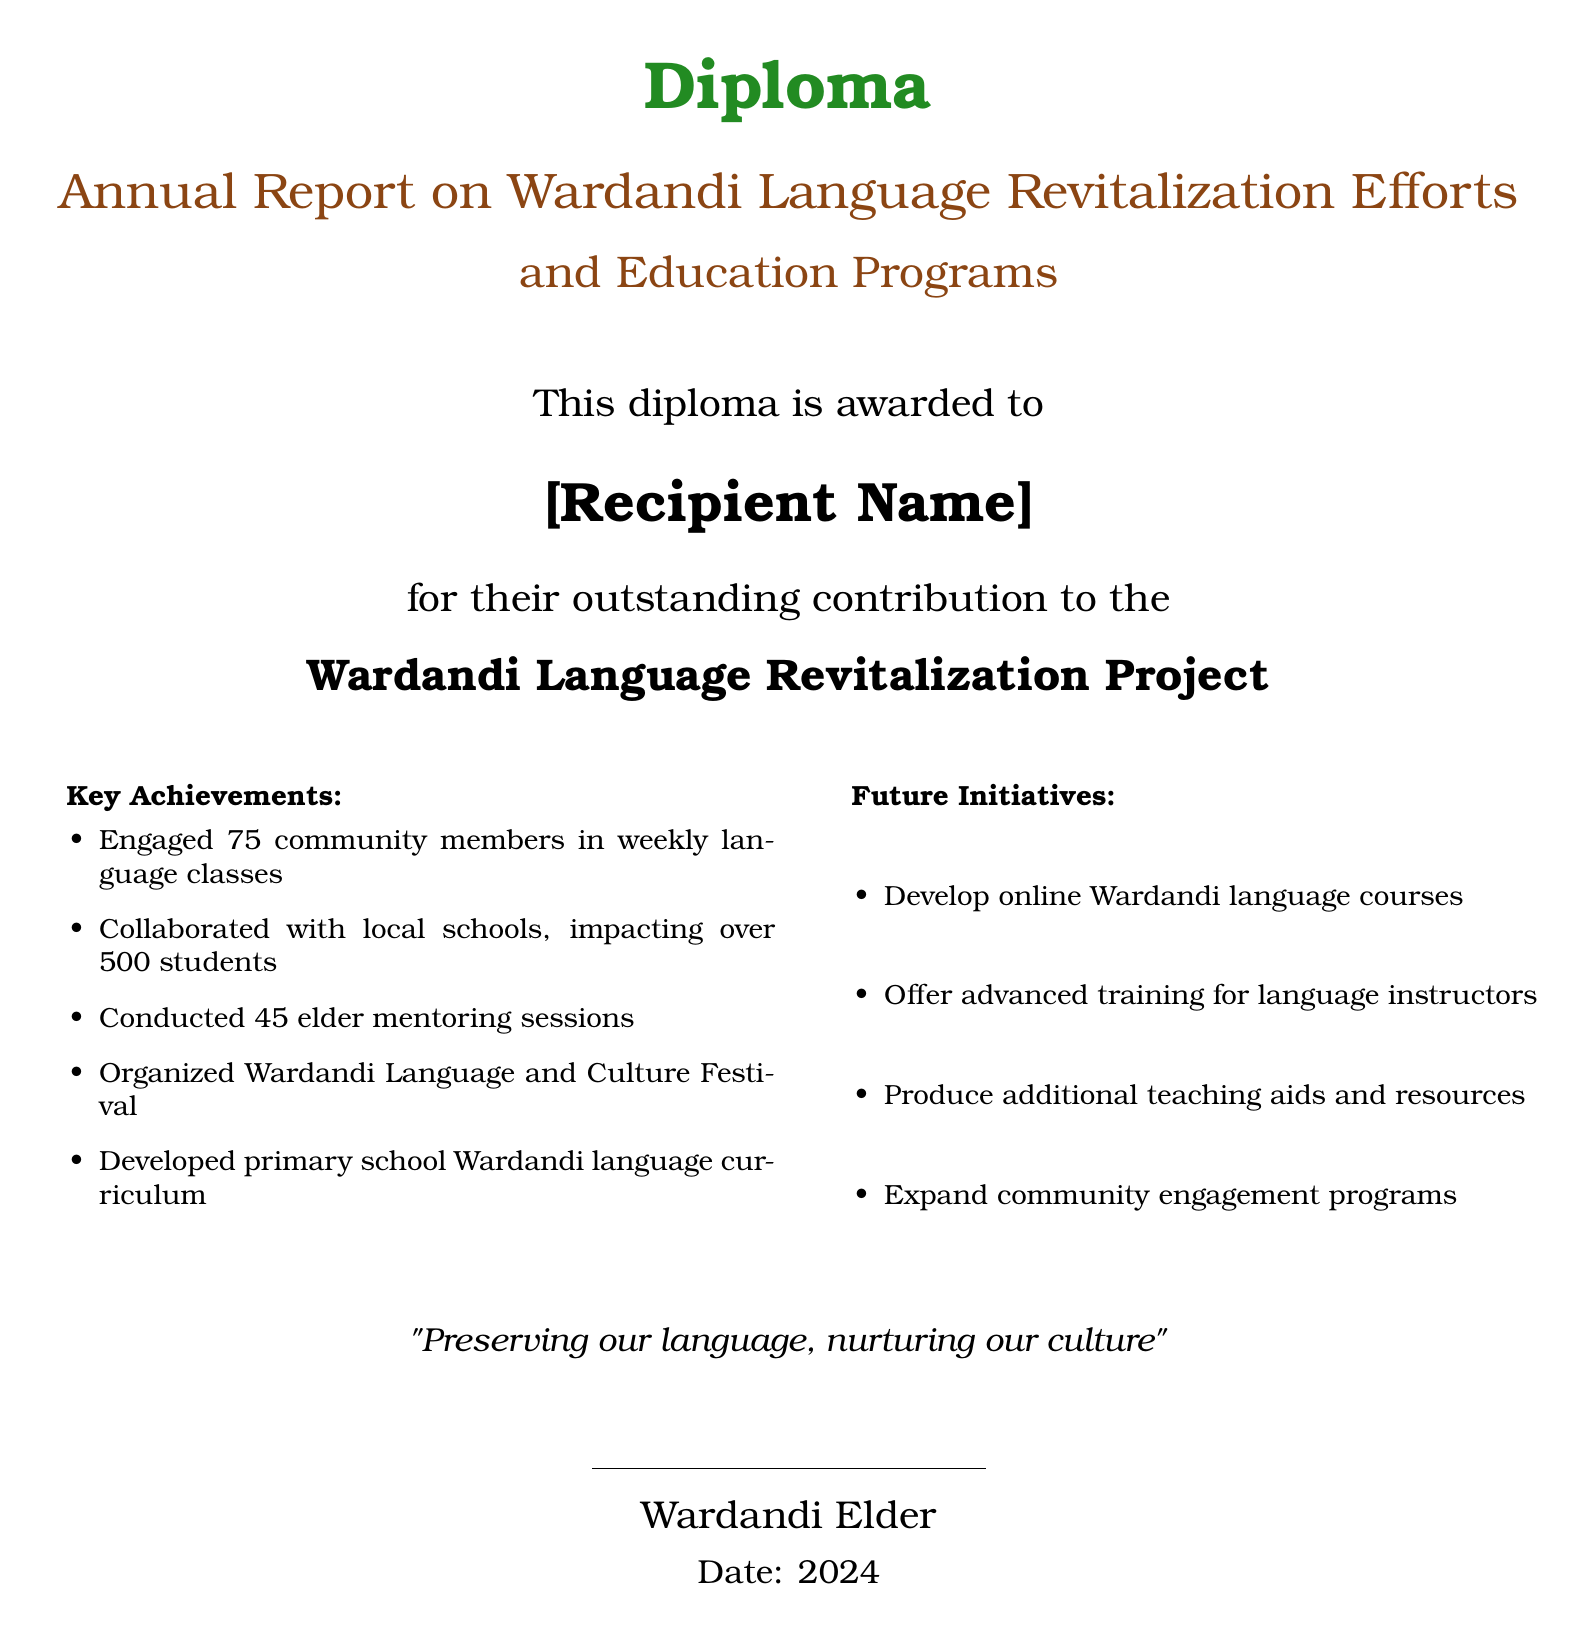What is awarded to the recipient? The document states that the diploma is awarded for outstanding contribution to the Wardandi Language Revitalization Project.
Answer: Diploma Who is the recipient of the diploma? The diploma includes a placeholder for the recipient's name.
Answer: [Recipient Name] How many community members engaged in weekly language classes? The document indicates a specific number of community members involved in the classes.
Answer: 75 How many students were impacted through collaboration with local schools? The report provides a number for the impact on students from local schools.
Answer: 500 What was organized as part of the language revitalization efforts? The document mentions an event aimed at promoting language and culture.
Answer: Wardandi Language and Culture Festival What is one of the future initiatives for Wardandi language courses? The document outlines future plans for language education.
Answer: Develop online Wardandi language courses How many elder mentoring sessions were conducted? The document specifies the number of mentoring sessions held.
Answer: 45 What is the quote included in the diploma? The diploma features a quote that reflects the purpose of the language revitalization.
Answer: "Preserving our language, nurturing our culture" What is the focus of the developed curriculum? The document mentions the focus of a curriculum developed as part of the project.
Answer: Wardandi language curriculum 